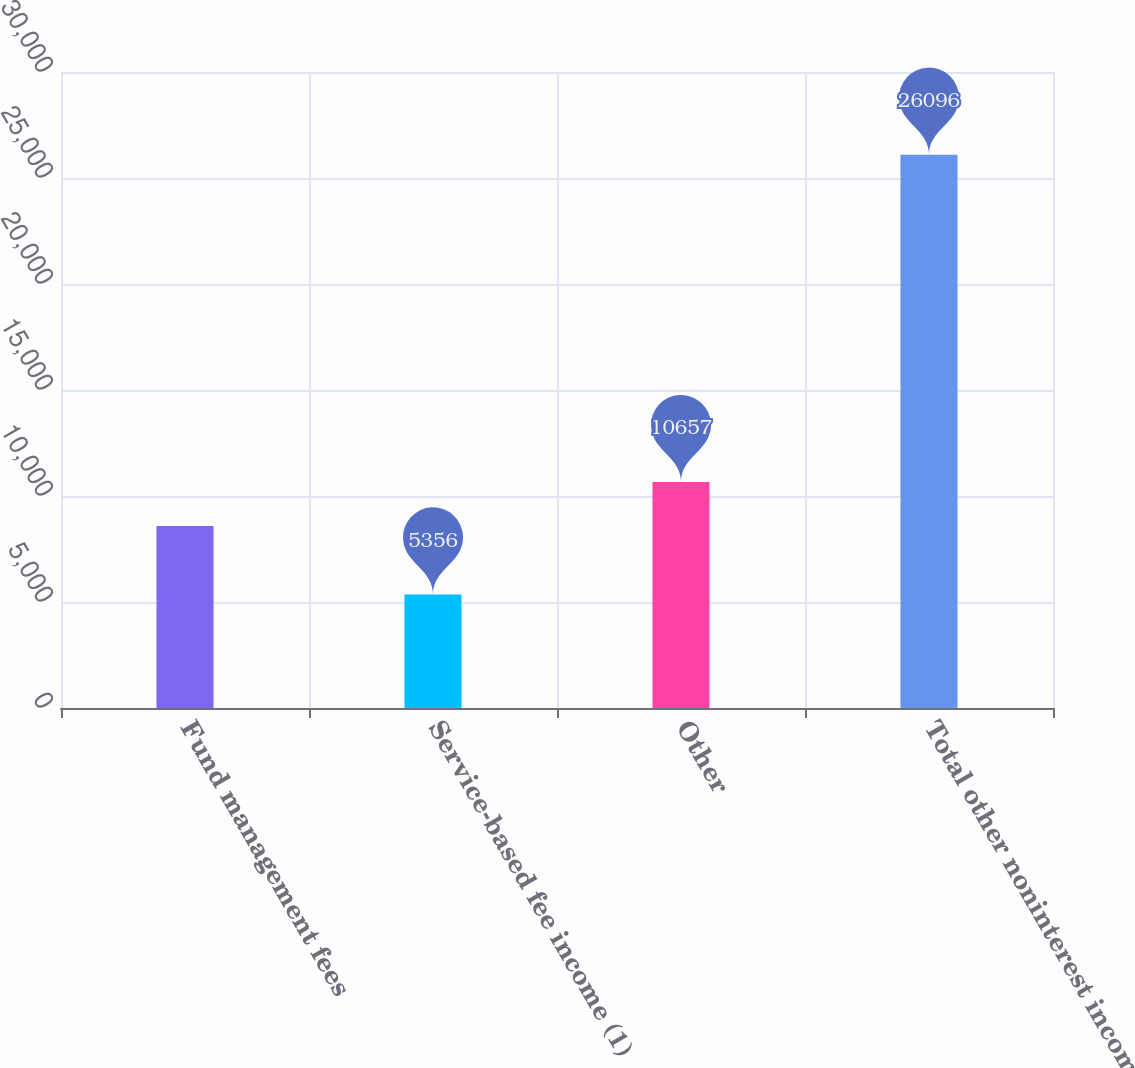Convert chart to OTSL. <chart><loc_0><loc_0><loc_500><loc_500><bar_chart><fcel>Fund management fees<fcel>Service-based fee income (1)<fcel>Other<fcel>Total other noninterest income<nl><fcel>8583<fcel>5356<fcel>10657<fcel>26096<nl></chart> 